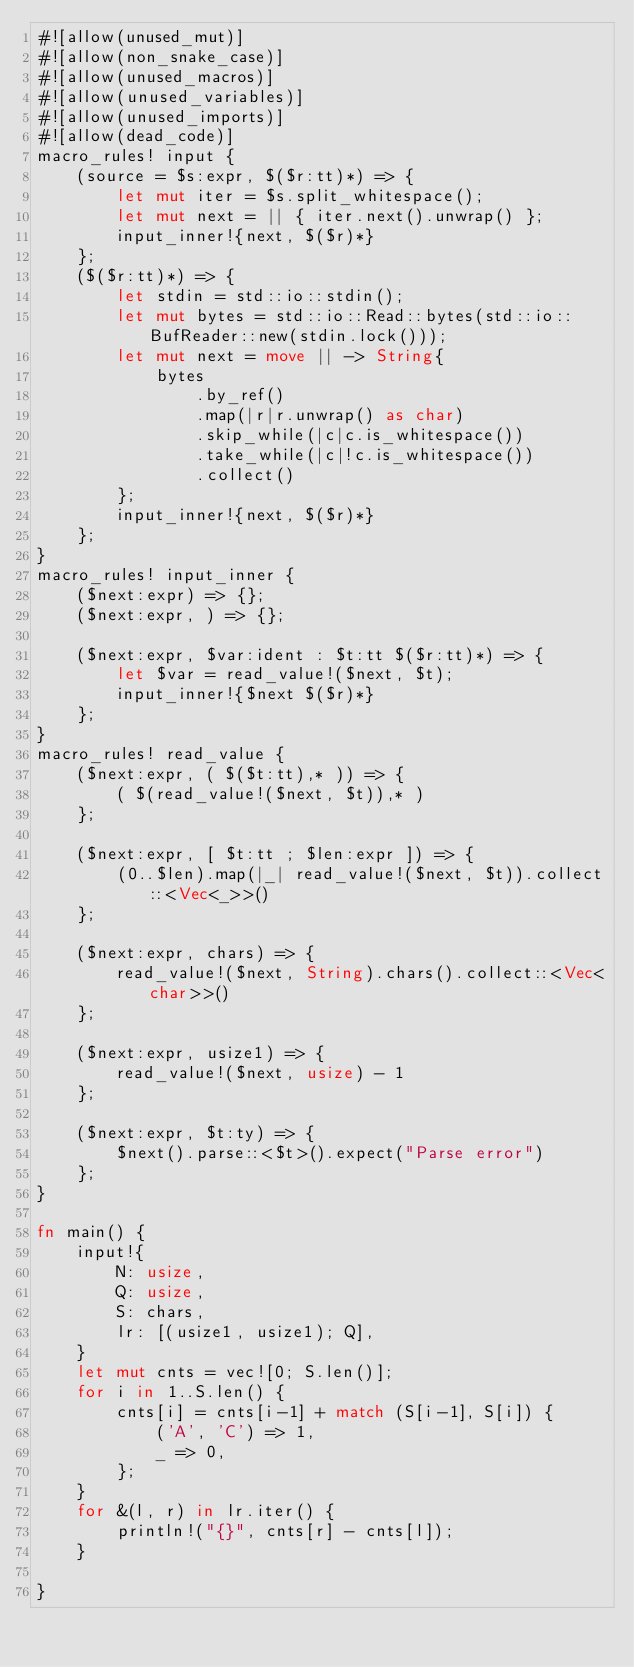<code> <loc_0><loc_0><loc_500><loc_500><_Rust_>#![allow(unused_mut)]
#![allow(non_snake_case)]
#![allow(unused_macros)]
#![allow(unused_variables)]
#![allow(unused_imports)]
#![allow(dead_code)]
macro_rules! input {
    (source = $s:expr, $($r:tt)*) => {
        let mut iter = $s.split_whitespace();
        let mut next = || { iter.next().unwrap() };
        input_inner!{next, $($r)*}
    };
    ($($r:tt)*) => {
        let stdin = std::io::stdin();
        let mut bytes = std::io::Read::bytes(std::io::BufReader::new(stdin.lock()));
        let mut next = move || -> String{
            bytes
                .by_ref()
                .map(|r|r.unwrap() as char)
                .skip_while(|c|c.is_whitespace())
                .take_while(|c|!c.is_whitespace())
                .collect()
        };
        input_inner!{next, $($r)*}
    };
}
macro_rules! input_inner {
    ($next:expr) => {};
    ($next:expr, ) => {};

    ($next:expr, $var:ident : $t:tt $($r:tt)*) => {
        let $var = read_value!($next, $t);
        input_inner!{$next $($r)*}
    };
}
macro_rules! read_value {
    ($next:expr, ( $($t:tt),* )) => {
        ( $(read_value!($next, $t)),* )
    };

    ($next:expr, [ $t:tt ; $len:expr ]) => {
        (0..$len).map(|_| read_value!($next, $t)).collect::<Vec<_>>()
    };

    ($next:expr, chars) => {
        read_value!($next, String).chars().collect::<Vec<char>>()
    };

    ($next:expr, usize1) => {
        read_value!($next, usize) - 1
    };

    ($next:expr, $t:ty) => {
        $next().parse::<$t>().expect("Parse error")
    };
}

fn main() {
    input!{
        N: usize,
        Q: usize,
        S: chars,
        lr: [(usize1, usize1); Q],
    }
    let mut cnts = vec![0; S.len()];
    for i in 1..S.len() {
        cnts[i] = cnts[i-1] + match (S[i-1], S[i]) {
            ('A', 'C') => 1,
            _ => 0,
        };
    }
    for &(l, r) in lr.iter() {
        println!("{}", cnts[r] - cnts[l]);
    }

}

</code> 